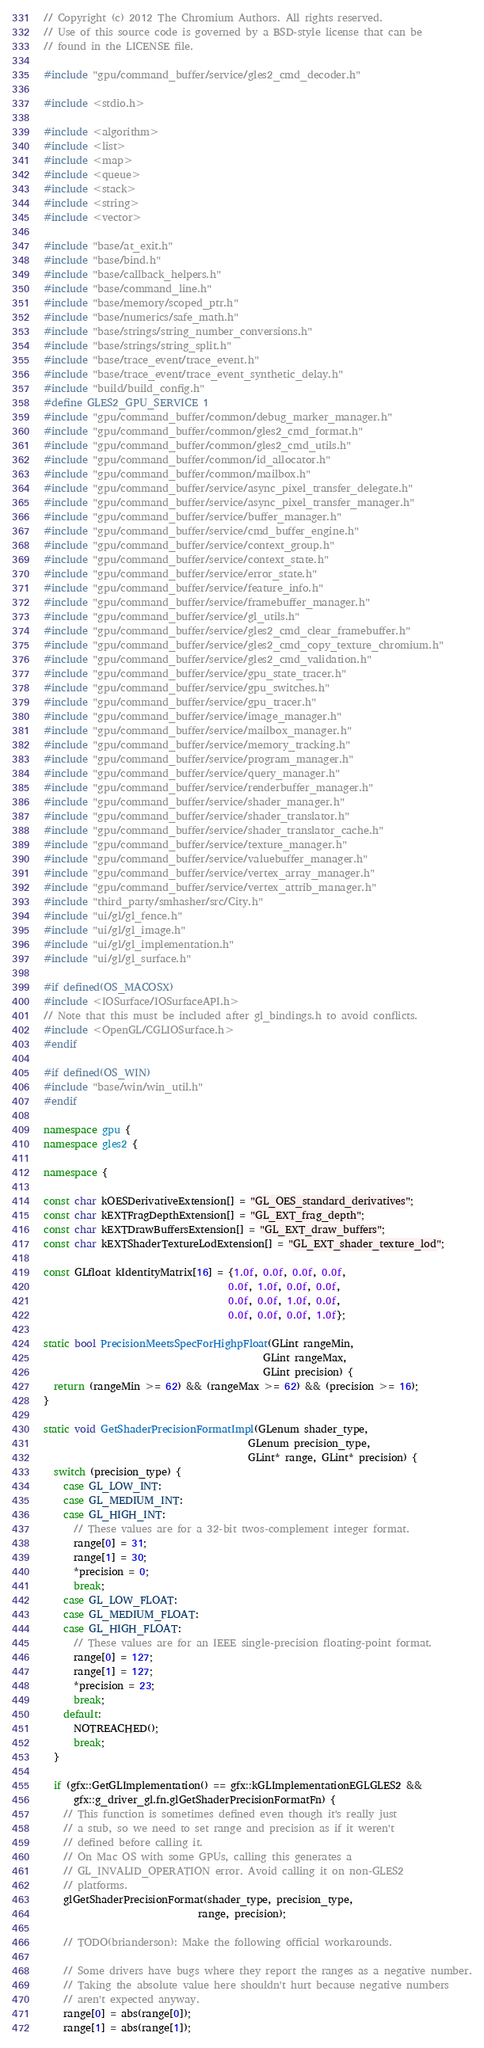<code> <loc_0><loc_0><loc_500><loc_500><_C++_>// Copyright (c) 2012 The Chromium Authors. All rights reserved.
// Use of this source code is governed by a BSD-style license that can be
// found in the LICENSE file.

#include "gpu/command_buffer/service/gles2_cmd_decoder.h"

#include <stdio.h>

#include <algorithm>
#include <list>
#include <map>
#include <queue>
#include <stack>
#include <string>
#include <vector>

#include "base/at_exit.h"
#include "base/bind.h"
#include "base/callback_helpers.h"
#include "base/command_line.h"
#include "base/memory/scoped_ptr.h"
#include "base/numerics/safe_math.h"
#include "base/strings/string_number_conversions.h"
#include "base/strings/string_split.h"
#include "base/trace_event/trace_event.h"
#include "base/trace_event/trace_event_synthetic_delay.h"
#include "build/build_config.h"
#define GLES2_GPU_SERVICE 1
#include "gpu/command_buffer/common/debug_marker_manager.h"
#include "gpu/command_buffer/common/gles2_cmd_format.h"
#include "gpu/command_buffer/common/gles2_cmd_utils.h"
#include "gpu/command_buffer/common/id_allocator.h"
#include "gpu/command_buffer/common/mailbox.h"
#include "gpu/command_buffer/service/async_pixel_transfer_delegate.h"
#include "gpu/command_buffer/service/async_pixel_transfer_manager.h"
#include "gpu/command_buffer/service/buffer_manager.h"
#include "gpu/command_buffer/service/cmd_buffer_engine.h"
#include "gpu/command_buffer/service/context_group.h"
#include "gpu/command_buffer/service/context_state.h"
#include "gpu/command_buffer/service/error_state.h"
#include "gpu/command_buffer/service/feature_info.h"
#include "gpu/command_buffer/service/framebuffer_manager.h"
#include "gpu/command_buffer/service/gl_utils.h"
#include "gpu/command_buffer/service/gles2_cmd_clear_framebuffer.h"
#include "gpu/command_buffer/service/gles2_cmd_copy_texture_chromium.h"
#include "gpu/command_buffer/service/gles2_cmd_validation.h"
#include "gpu/command_buffer/service/gpu_state_tracer.h"
#include "gpu/command_buffer/service/gpu_switches.h"
#include "gpu/command_buffer/service/gpu_tracer.h"
#include "gpu/command_buffer/service/image_manager.h"
#include "gpu/command_buffer/service/mailbox_manager.h"
#include "gpu/command_buffer/service/memory_tracking.h"
#include "gpu/command_buffer/service/program_manager.h"
#include "gpu/command_buffer/service/query_manager.h"
#include "gpu/command_buffer/service/renderbuffer_manager.h"
#include "gpu/command_buffer/service/shader_manager.h"
#include "gpu/command_buffer/service/shader_translator.h"
#include "gpu/command_buffer/service/shader_translator_cache.h"
#include "gpu/command_buffer/service/texture_manager.h"
#include "gpu/command_buffer/service/valuebuffer_manager.h"
#include "gpu/command_buffer/service/vertex_array_manager.h"
#include "gpu/command_buffer/service/vertex_attrib_manager.h"
#include "third_party/smhasher/src/City.h"
#include "ui/gl/gl_fence.h"
#include "ui/gl/gl_image.h"
#include "ui/gl/gl_implementation.h"
#include "ui/gl/gl_surface.h"

#if defined(OS_MACOSX)
#include <IOSurface/IOSurfaceAPI.h>
// Note that this must be included after gl_bindings.h to avoid conflicts.
#include <OpenGL/CGLIOSurface.h>
#endif

#if defined(OS_WIN)
#include "base/win/win_util.h"
#endif

namespace gpu {
namespace gles2 {

namespace {

const char kOESDerivativeExtension[] = "GL_OES_standard_derivatives";
const char kEXTFragDepthExtension[] = "GL_EXT_frag_depth";
const char kEXTDrawBuffersExtension[] = "GL_EXT_draw_buffers";
const char kEXTShaderTextureLodExtension[] = "GL_EXT_shader_texture_lod";

const GLfloat kIdentityMatrix[16] = {1.0f, 0.0f, 0.0f, 0.0f,
                                     0.0f, 1.0f, 0.0f, 0.0f,
                                     0.0f, 0.0f, 1.0f, 0.0f,
                                     0.0f, 0.0f, 0.0f, 1.0f};

static bool PrecisionMeetsSpecForHighpFloat(GLint rangeMin,
                                            GLint rangeMax,
                                            GLint precision) {
  return (rangeMin >= 62) && (rangeMax >= 62) && (precision >= 16);
}

static void GetShaderPrecisionFormatImpl(GLenum shader_type,
                                         GLenum precision_type,
                                         GLint* range, GLint* precision) {
  switch (precision_type) {
    case GL_LOW_INT:
    case GL_MEDIUM_INT:
    case GL_HIGH_INT:
      // These values are for a 32-bit twos-complement integer format.
      range[0] = 31;
      range[1] = 30;
      *precision = 0;
      break;
    case GL_LOW_FLOAT:
    case GL_MEDIUM_FLOAT:
    case GL_HIGH_FLOAT:
      // These values are for an IEEE single-precision floating-point format.
      range[0] = 127;
      range[1] = 127;
      *precision = 23;
      break;
    default:
      NOTREACHED();
      break;
  }

  if (gfx::GetGLImplementation() == gfx::kGLImplementationEGLGLES2 &&
      gfx::g_driver_gl.fn.glGetShaderPrecisionFormatFn) {
    // This function is sometimes defined even though it's really just
    // a stub, so we need to set range and precision as if it weren't
    // defined before calling it.
    // On Mac OS with some GPUs, calling this generates a
    // GL_INVALID_OPERATION error. Avoid calling it on non-GLES2
    // platforms.
    glGetShaderPrecisionFormat(shader_type, precision_type,
                               range, precision);

    // TODO(brianderson): Make the following official workarounds.

    // Some drivers have bugs where they report the ranges as a negative number.
    // Taking the absolute value here shouldn't hurt because negative numbers
    // aren't expected anyway.
    range[0] = abs(range[0]);
    range[1] = abs(range[1]);
</code> 